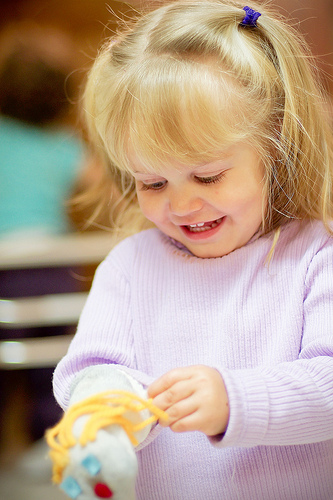<image>
Is there a puppet on the girl? Yes. Looking at the image, I can see the puppet is positioned on top of the girl, with the girl providing support. Is the puppet next to the girl? No. The puppet is not positioned next to the girl. They are located in different areas of the scene. 